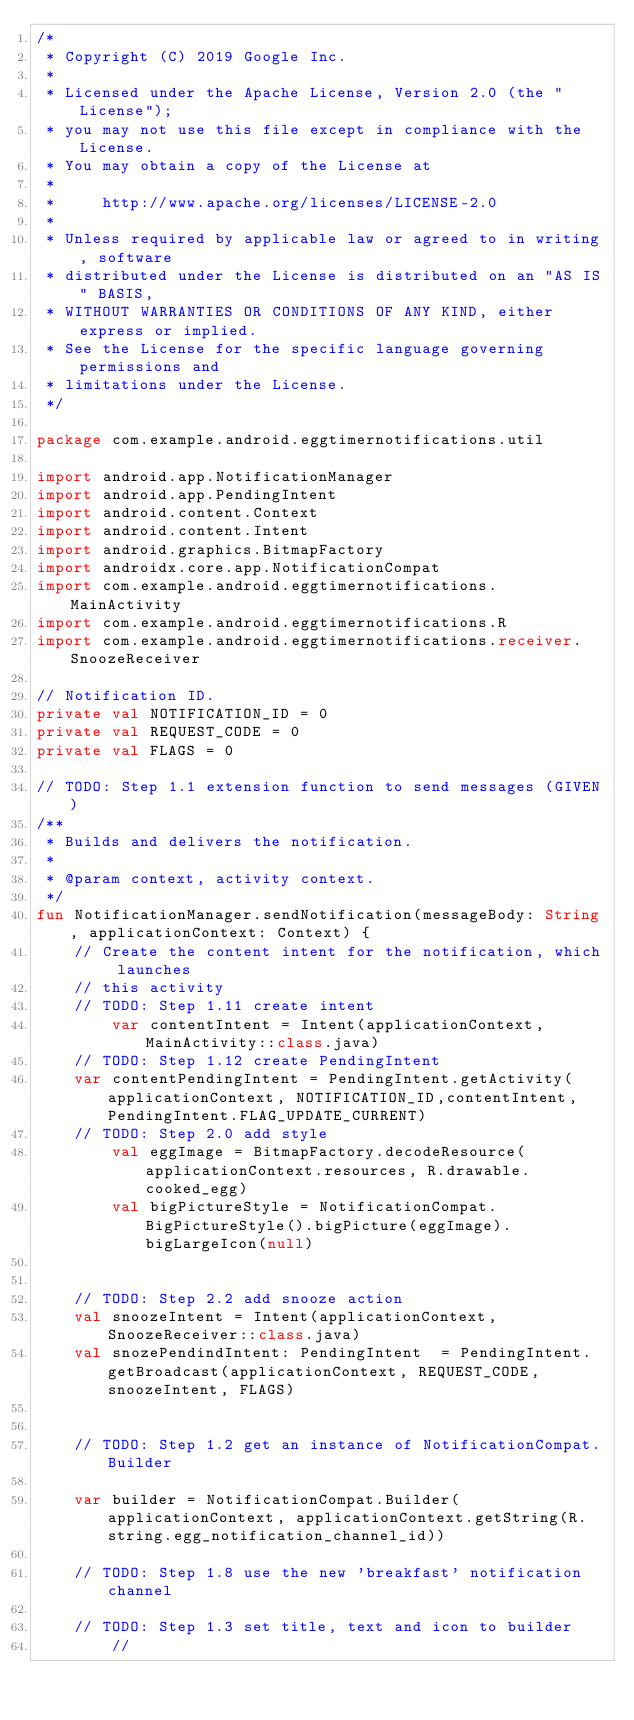Convert code to text. <code><loc_0><loc_0><loc_500><loc_500><_Kotlin_>/*
 * Copyright (C) 2019 Google Inc.
 *
 * Licensed under the Apache License, Version 2.0 (the "License");
 * you may not use this file except in compliance with the License.
 * You may obtain a copy of the License at
 *
 *     http://www.apache.org/licenses/LICENSE-2.0
 *
 * Unless required by applicable law or agreed to in writing, software
 * distributed under the License is distributed on an "AS IS" BASIS,
 * WITHOUT WARRANTIES OR CONDITIONS OF ANY KIND, either express or implied.
 * See the License for the specific language governing permissions and
 * limitations under the License.
 */

package com.example.android.eggtimernotifications.util

import android.app.NotificationManager
import android.app.PendingIntent
import android.content.Context
import android.content.Intent
import android.graphics.BitmapFactory
import androidx.core.app.NotificationCompat
import com.example.android.eggtimernotifications.MainActivity
import com.example.android.eggtimernotifications.R
import com.example.android.eggtimernotifications.receiver.SnoozeReceiver

// Notification ID.
private val NOTIFICATION_ID = 0
private val REQUEST_CODE = 0
private val FLAGS = 0

// TODO: Step 1.1 extension function to send messages (GIVEN)
/**
 * Builds and delivers the notification.
 *
 * @param context, activity context.
 */
fun NotificationManager.sendNotification(messageBody: String, applicationContext: Context) {
    // Create the content intent for the notification, which launches
    // this activity
    // TODO: Step 1.11 create intent
        var contentIntent = Intent(applicationContext, MainActivity::class.java)
    // TODO: Step 1.12 create PendingIntent
    var contentPendingIntent = PendingIntent.getActivity(applicationContext, NOTIFICATION_ID,contentIntent, PendingIntent.FLAG_UPDATE_CURRENT)
    // TODO: Step 2.0 add style
        val eggImage = BitmapFactory.decodeResource(applicationContext.resources, R.drawable.cooked_egg)
        val bigPictureStyle = NotificationCompat.BigPictureStyle().bigPicture(eggImage).bigLargeIcon(null)


    // TODO: Step 2.2 add snooze action
    val snoozeIntent = Intent(applicationContext, SnoozeReceiver::class.java)
    val snozePendindIntent: PendingIntent  = PendingIntent.getBroadcast(applicationContext, REQUEST_CODE, snoozeIntent, FLAGS)


    // TODO: Step 1.2 get an instance of NotificationCompat.Builder

    var builder = NotificationCompat.Builder(applicationContext, applicationContext.getString(R.string.egg_notification_channel_id))

    // TODO: Step 1.8 use the new 'breakfast' notification channel

    // TODO: Step 1.3 set title, text and icon to builder
        //</code> 